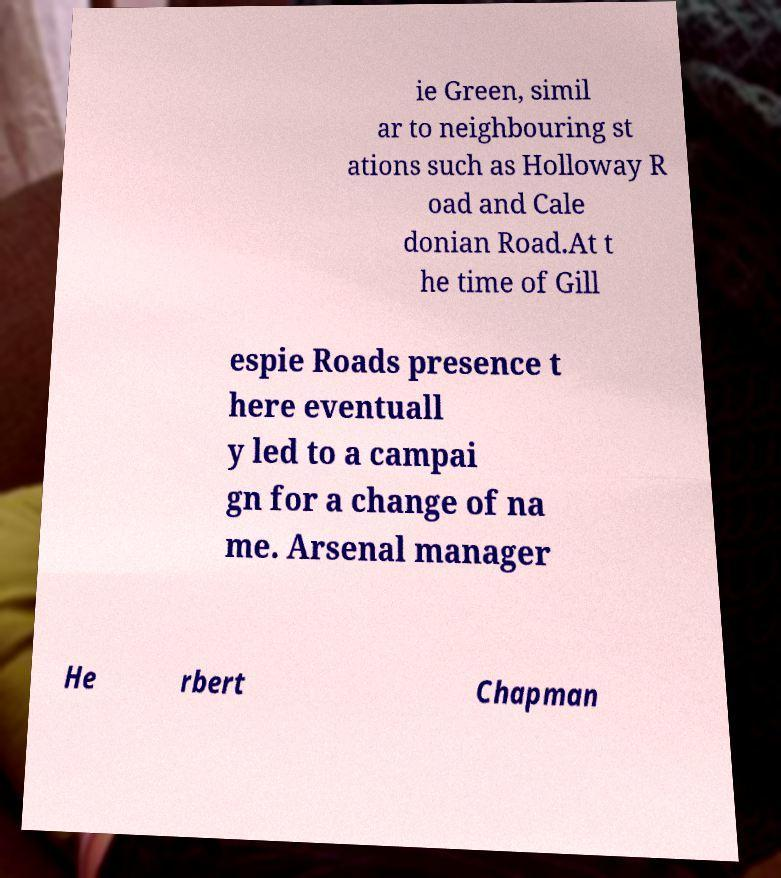Can you read and provide the text displayed in the image?This photo seems to have some interesting text. Can you extract and type it out for me? ie Green, simil ar to neighbouring st ations such as Holloway R oad and Cale donian Road.At t he time of Gill espie Roads presence t here eventuall y led to a campai gn for a change of na me. Arsenal manager He rbert Chapman 